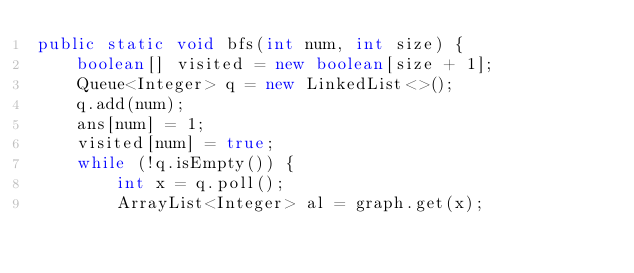Convert code to text. <code><loc_0><loc_0><loc_500><loc_500><_Java_>public static void bfs(int num, int size) {
    boolean[] visited = new boolean[size + 1];
    Queue<Integer> q = new LinkedList<>();
    q.add(num);
    ans[num] = 1;
    visited[num] = true;
    while (!q.isEmpty()) {
        int x = q.poll();
        ArrayList<Integer> al = graph.get(x);</code> 